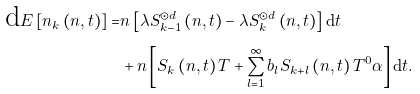<formula> <loc_0><loc_0><loc_500><loc_500>\text {d} E \left [ n _ { k } \left ( n , t \right ) \right ] = & n \left [ \lambda S _ { k - 1 } ^ { \odot d } \left ( n , t \right ) - \lambda S _ { k } ^ { \odot d } \left ( n , t \right ) \right ] \text {d} t \\ & + n \left [ S _ { k } \left ( n , t \right ) T + \sum _ { l = 1 } ^ { \infty } b _ { l } S _ { k + l } \left ( n , t \right ) T ^ { 0 } \alpha \right ] \text {d} t .</formula> 